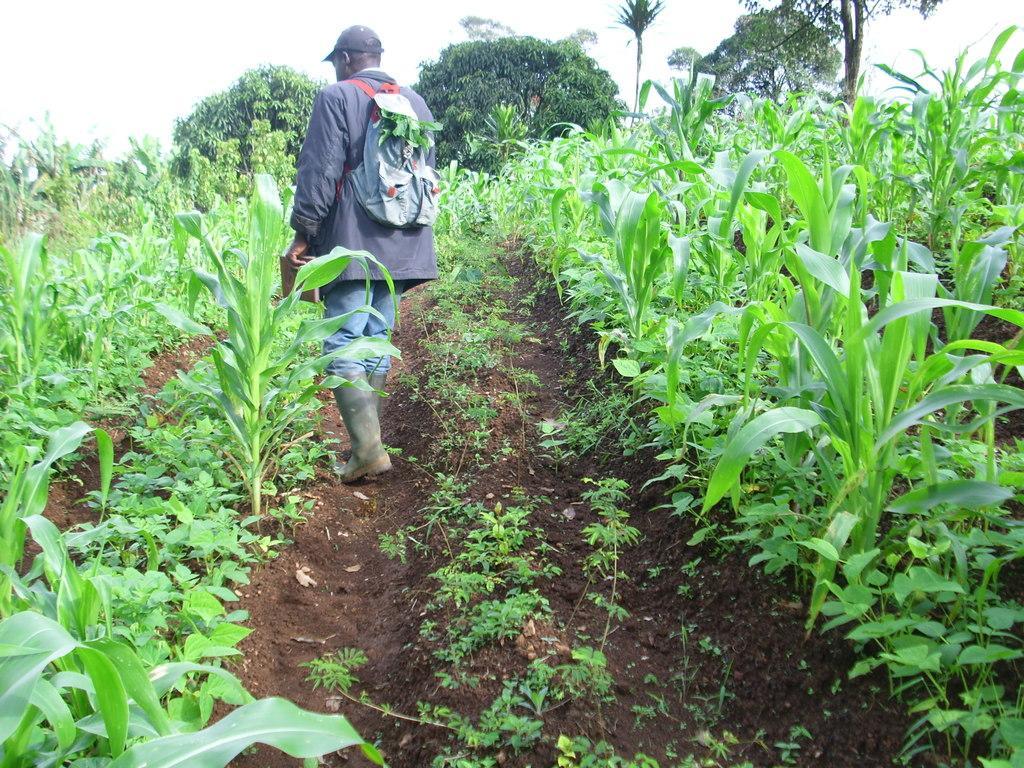Describe this image in one or two sentences. In this image we can see a person holding an object. Around the person there are group of plants. Behind the person we can see a group of trees. At the top we can see the sky. 